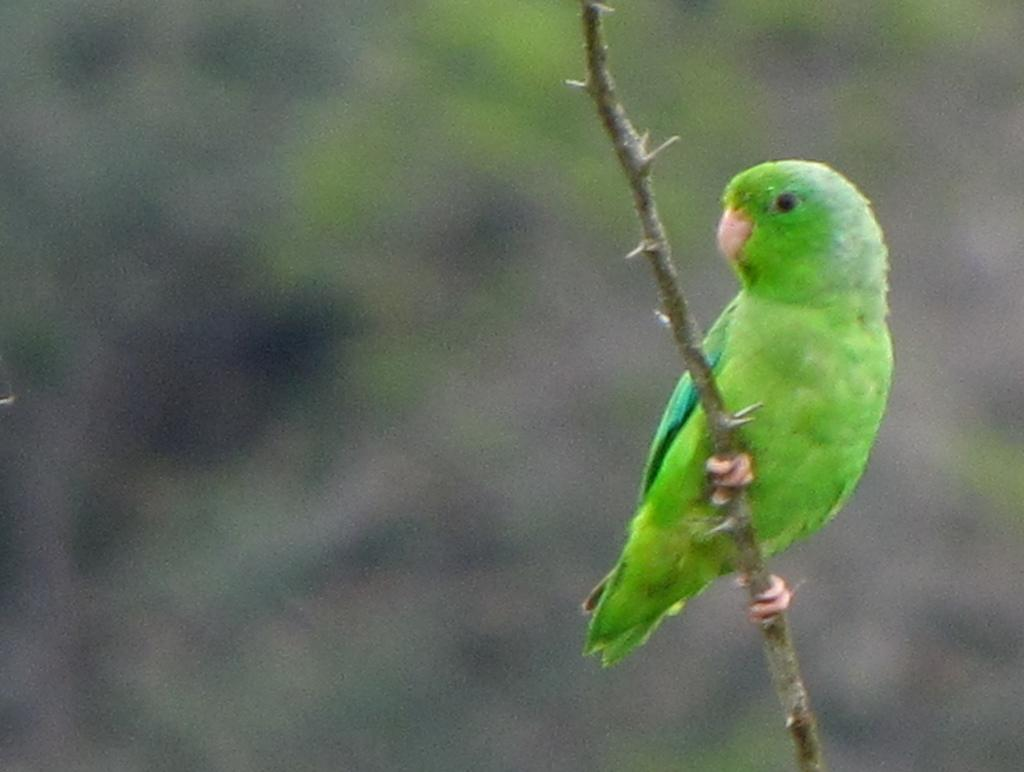What type of animal is in the picture? There is a parrot in the picture. Where is the parrot located in the image? The parrot is sitting on a stem. What color bead is the parrot holding in its beak in the image? There is no bead present in the image, and the parrot is not holding anything in its beak. 